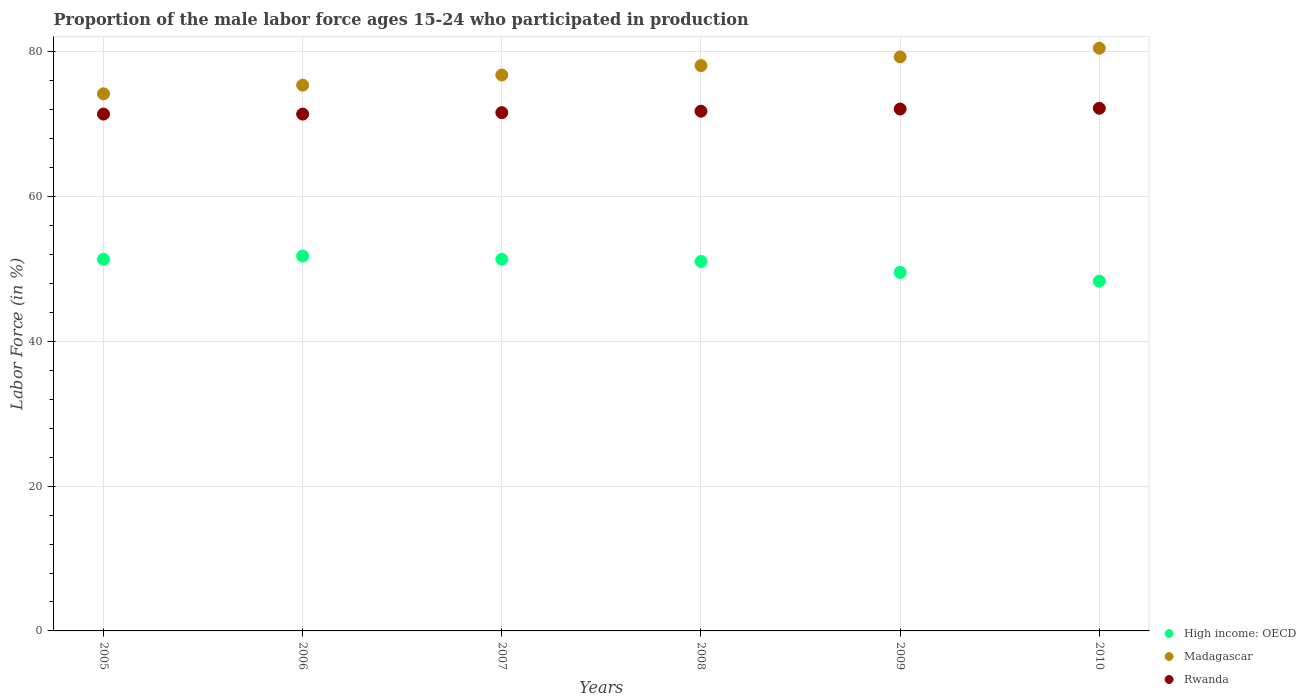What is the proportion of the male labor force who participated in production in Rwanda in 2005?
Your answer should be compact. 71.4. Across all years, what is the maximum proportion of the male labor force who participated in production in High income: OECD?
Provide a succinct answer. 51.79. Across all years, what is the minimum proportion of the male labor force who participated in production in Madagascar?
Ensure brevity in your answer.  74.2. In which year was the proportion of the male labor force who participated in production in High income: OECD maximum?
Your answer should be very brief. 2006. In which year was the proportion of the male labor force who participated in production in Madagascar minimum?
Your response must be concise. 2005. What is the total proportion of the male labor force who participated in production in Rwanda in the graph?
Your response must be concise. 430.5. What is the difference between the proportion of the male labor force who participated in production in High income: OECD in 2009 and that in 2010?
Give a very brief answer. 1.21. What is the difference between the proportion of the male labor force who participated in production in High income: OECD in 2005 and the proportion of the male labor force who participated in production in Madagascar in 2007?
Your answer should be very brief. -25.45. What is the average proportion of the male labor force who participated in production in High income: OECD per year?
Your response must be concise. 50.56. In the year 2005, what is the difference between the proportion of the male labor force who participated in production in High income: OECD and proportion of the male labor force who participated in production in Madagascar?
Your answer should be compact. -22.85. What is the ratio of the proportion of the male labor force who participated in production in Madagascar in 2007 to that in 2008?
Your response must be concise. 0.98. Is the difference between the proportion of the male labor force who participated in production in High income: OECD in 2005 and 2007 greater than the difference between the proportion of the male labor force who participated in production in Madagascar in 2005 and 2007?
Provide a succinct answer. Yes. What is the difference between the highest and the second highest proportion of the male labor force who participated in production in Rwanda?
Ensure brevity in your answer.  0.1. What is the difference between the highest and the lowest proportion of the male labor force who participated in production in Rwanda?
Offer a very short reply. 0.8. Is it the case that in every year, the sum of the proportion of the male labor force who participated in production in Rwanda and proportion of the male labor force who participated in production in Madagascar  is greater than the proportion of the male labor force who participated in production in High income: OECD?
Your answer should be compact. Yes. Is the proportion of the male labor force who participated in production in High income: OECD strictly greater than the proportion of the male labor force who participated in production in Madagascar over the years?
Provide a short and direct response. No. Is the proportion of the male labor force who participated in production in Madagascar strictly less than the proportion of the male labor force who participated in production in High income: OECD over the years?
Ensure brevity in your answer.  No. What is the difference between two consecutive major ticks on the Y-axis?
Provide a short and direct response. 20. Are the values on the major ticks of Y-axis written in scientific E-notation?
Your answer should be very brief. No. Does the graph contain grids?
Offer a very short reply. Yes. Where does the legend appear in the graph?
Keep it short and to the point. Bottom right. How many legend labels are there?
Provide a succinct answer. 3. What is the title of the graph?
Offer a very short reply. Proportion of the male labor force ages 15-24 who participated in production. What is the Labor Force (in %) of High income: OECD in 2005?
Make the answer very short. 51.35. What is the Labor Force (in %) in Madagascar in 2005?
Offer a very short reply. 74.2. What is the Labor Force (in %) of Rwanda in 2005?
Your response must be concise. 71.4. What is the Labor Force (in %) of High income: OECD in 2006?
Provide a succinct answer. 51.79. What is the Labor Force (in %) of Madagascar in 2006?
Your answer should be very brief. 75.4. What is the Labor Force (in %) of Rwanda in 2006?
Give a very brief answer. 71.4. What is the Labor Force (in %) of High income: OECD in 2007?
Your answer should be compact. 51.35. What is the Labor Force (in %) in Madagascar in 2007?
Your answer should be very brief. 76.8. What is the Labor Force (in %) in Rwanda in 2007?
Your answer should be very brief. 71.6. What is the Labor Force (in %) of High income: OECD in 2008?
Offer a very short reply. 51.04. What is the Labor Force (in %) in Madagascar in 2008?
Offer a very short reply. 78.1. What is the Labor Force (in %) of Rwanda in 2008?
Give a very brief answer. 71.8. What is the Labor Force (in %) in High income: OECD in 2009?
Provide a succinct answer. 49.54. What is the Labor Force (in %) in Madagascar in 2009?
Your answer should be compact. 79.3. What is the Labor Force (in %) in Rwanda in 2009?
Make the answer very short. 72.1. What is the Labor Force (in %) in High income: OECD in 2010?
Provide a short and direct response. 48.33. What is the Labor Force (in %) of Madagascar in 2010?
Give a very brief answer. 80.5. What is the Labor Force (in %) in Rwanda in 2010?
Make the answer very short. 72.2. Across all years, what is the maximum Labor Force (in %) of High income: OECD?
Your response must be concise. 51.79. Across all years, what is the maximum Labor Force (in %) in Madagascar?
Provide a short and direct response. 80.5. Across all years, what is the maximum Labor Force (in %) of Rwanda?
Make the answer very short. 72.2. Across all years, what is the minimum Labor Force (in %) of High income: OECD?
Provide a short and direct response. 48.33. Across all years, what is the minimum Labor Force (in %) of Madagascar?
Provide a succinct answer. 74.2. Across all years, what is the minimum Labor Force (in %) of Rwanda?
Provide a succinct answer. 71.4. What is the total Labor Force (in %) in High income: OECD in the graph?
Provide a succinct answer. 303.39. What is the total Labor Force (in %) of Madagascar in the graph?
Provide a short and direct response. 464.3. What is the total Labor Force (in %) of Rwanda in the graph?
Ensure brevity in your answer.  430.5. What is the difference between the Labor Force (in %) of High income: OECD in 2005 and that in 2006?
Ensure brevity in your answer.  -0.44. What is the difference between the Labor Force (in %) of Rwanda in 2005 and that in 2006?
Your answer should be very brief. 0. What is the difference between the Labor Force (in %) in High income: OECD in 2005 and that in 2007?
Your response must be concise. -0. What is the difference between the Labor Force (in %) in High income: OECD in 2005 and that in 2008?
Give a very brief answer. 0.31. What is the difference between the Labor Force (in %) of High income: OECD in 2005 and that in 2009?
Give a very brief answer. 1.81. What is the difference between the Labor Force (in %) in Madagascar in 2005 and that in 2009?
Offer a very short reply. -5.1. What is the difference between the Labor Force (in %) in Rwanda in 2005 and that in 2009?
Provide a succinct answer. -0.7. What is the difference between the Labor Force (in %) in High income: OECD in 2005 and that in 2010?
Give a very brief answer. 3.02. What is the difference between the Labor Force (in %) in Madagascar in 2005 and that in 2010?
Offer a very short reply. -6.3. What is the difference between the Labor Force (in %) in High income: OECD in 2006 and that in 2007?
Keep it short and to the point. 0.44. What is the difference between the Labor Force (in %) of Madagascar in 2006 and that in 2007?
Your answer should be compact. -1.4. What is the difference between the Labor Force (in %) in Rwanda in 2006 and that in 2007?
Your answer should be very brief. -0.2. What is the difference between the Labor Force (in %) in High income: OECD in 2006 and that in 2008?
Provide a short and direct response. 0.75. What is the difference between the Labor Force (in %) in Rwanda in 2006 and that in 2008?
Provide a short and direct response. -0.4. What is the difference between the Labor Force (in %) in High income: OECD in 2006 and that in 2009?
Give a very brief answer. 2.25. What is the difference between the Labor Force (in %) of Madagascar in 2006 and that in 2009?
Offer a very short reply. -3.9. What is the difference between the Labor Force (in %) in Rwanda in 2006 and that in 2009?
Your answer should be very brief. -0.7. What is the difference between the Labor Force (in %) of High income: OECD in 2006 and that in 2010?
Ensure brevity in your answer.  3.46. What is the difference between the Labor Force (in %) in Madagascar in 2006 and that in 2010?
Keep it short and to the point. -5.1. What is the difference between the Labor Force (in %) in High income: OECD in 2007 and that in 2008?
Provide a succinct answer. 0.31. What is the difference between the Labor Force (in %) of Rwanda in 2007 and that in 2008?
Offer a terse response. -0.2. What is the difference between the Labor Force (in %) of High income: OECD in 2007 and that in 2009?
Offer a terse response. 1.82. What is the difference between the Labor Force (in %) of Rwanda in 2007 and that in 2009?
Your answer should be compact. -0.5. What is the difference between the Labor Force (in %) of High income: OECD in 2007 and that in 2010?
Your answer should be very brief. 3.03. What is the difference between the Labor Force (in %) in Rwanda in 2007 and that in 2010?
Your response must be concise. -0.6. What is the difference between the Labor Force (in %) of High income: OECD in 2008 and that in 2009?
Ensure brevity in your answer.  1.5. What is the difference between the Labor Force (in %) in High income: OECD in 2008 and that in 2010?
Ensure brevity in your answer.  2.71. What is the difference between the Labor Force (in %) of Madagascar in 2008 and that in 2010?
Your answer should be very brief. -2.4. What is the difference between the Labor Force (in %) of Rwanda in 2008 and that in 2010?
Make the answer very short. -0.4. What is the difference between the Labor Force (in %) of High income: OECD in 2009 and that in 2010?
Provide a succinct answer. 1.21. What is the difference between the Labor Force (in %) of Madagascar in 2009 and that in 2010?
Offer a very short reply. -1.2. What is the difference between the Labor Force (in %) of Rwanda in 2009 and that in 2010?
Keep it short and to the point. -0.1. What is the difference between the Labor Force (in %) in High income: OECD in 2005 and the Labor Force (in %) in Madagascar in 2006?
Ensure brevity in your answer.  -24.05. What is the difference between the Labor Force (in %) in High income: OECD in 2005 and the Labor Force (in %) in Rwanda in 2006?
Your answer should be compact. -20.05. What is the difference between the Labor Force (in %) of High income: OECD in 2005 and the Labor Force (in %) of Madagascar in 2007?
Ensure brevity in your answer.  -25.45. What is the difference between the Labor Force (in %) in High income: OECD in 2005 and the Labor Force (in %) in Rwanda in 2007?
Your answer should be compact. -20.25. What is the difference between the Labor Force (in %) of High income: OECD in 2005 and the Labor Force (in %) of Madagascar in 2008?
Ensure brevity in your answer.  -26.75. What is the difference between the Labor Force (in %) of High income: OECD in 2005 and the Labor Force (in %) of Rwanda in 2008?
Keep it short and to the point. -20.45. What is the difference between the Labor Force (in %) of High income: OECD in 2005 and the Labor Force (in %) of Madagascar in 2009?
Your answer should be very brief. -27.95. What is the difference between the Labor Force (in %) in High income: OECD in 2005 and the Labor Force (in %) in Rwanda in 2009?
Offer a terse response. -20.75. What is the difference between the Labor Force (in %) in High income: OECD in 2005 and the Labor Force (in %) in Madagascar in 2010?
Keep it short and to the point. -29.15. What is the difference between the Labor Force (in %) in High income: OECD in 2005 and the Labor Force (in %) in Rwanda in 2010?
Offer a very short reply. -20.85. What is the difference between the Labor Force (in %) in Madagascar in 2005 and the Labor Force (in %) in Rwanda in 2010?
Provide a succinct answer. 2. What is the difference between the Labor Force (in %) of High income: OECD in 2006 and the Labor Force (in %) of Madagascar in 2007?
Your response must be concise. -25.01. What is the difference between the Labor Force (in %) in High income: OECD in 2006 and the Labor Force (in %) in Rwanda in 2007?
Your response must be concise. -19.81. What is the difference between the Labor Force (in %) of High income: OECD in 2006 and the Labor Force (in %) of Madagascar in 2008?
Offer a terse response. -26.31. What is the difference between the Labor Force (in %) of High income: OECD in 2006 and the Labor Force (in %) of Rwanda in 2008?
Make the answer very short. -20.01. What is the difference between the Labor Force (in %) in High income: OECD in 2006 and the Labor Force (in %) in Madagascar in 2009?
Provide a short and direct response. -27.51. What is the difference between the Labor Force (in %) of High income: OECD in 2006 and the Labor Force (in %) of Rwanda in 2009?
Provide a short and direct response. -20.31. What is the difference between the Labor Force (in %) of Madagascar in 2006 and the Labor Force (in %) of Rwanda in 2009?
Your response must be concise. 3.3. What is the difference between the Labor Force (in %) of High income: OECD in 2006 and the Labor Force (in %) of Madagascar in 2010?
Ensure brevity in your answer.  -28.71. What is the difference between the Labor Force (in %) of High income: OECD in 2006 and the Labor Force (in %) of Rwanda in 2010?
Offer a terse response. -20.41. What is the difference between the Labor Force (in %) of High income: OECD in 2007 and the Labor Force (in %) of Madagascar in 2008?
Offer a very short reply. -26.75. What is the difference between the Labor Force (in %) in High income: OECD in 2007 and the Labor Force (in %) in Rwanda in 2008?
Offer a very short reply. -20.45. What is the difference between the Labor Force (in %) of Madagascar in 2007 and the Labor Force (in %) of Rwanda in 2008?
Offer a terse response. 5. What is the difference between the Labor Force (in %) in High income: OECD in 2007 and the Labor Force (in %) in Madagascar in 2009?
Make the answer very short. -27.95. What is the difference between the Labor Force (in %) of High income: OECD in 2007 and the Labor Force (in %) of Rwanda in 2009?
Give a very brief answer. -20.75. What is the difference between the Labor Force (in %) in High income: OECD in 2007 and the Labor Force (in %) in Madagascar in 2010?
Provide a succinct answer. -29.15. What is the difference between the Labor Force (in %) in High income: OECD in 2007 and the Labor Force (in %) in Rwanda in 2010?
Provide a succinct answer. -20.85. What is the difference between the Labor Force (in %) of Madagascar in 2007 and the Labor Force (in %) of Rwanda in 2010?
Make the answer very short. 4.6. What is the difference between the Labor Force (in %) of High income: OECD in 2008 and the Labor Force (in %) of Madagascar in 2009?
Provide a succinct answer. -28.26. What is the difference between the Labor Force (in %) of High income: OECD in 2008 and the Labor Force (in %) of Rwanda in 2009?
Give a very brief answer. -21.06. What is the difference between the Labor Force (in %) in Madagascar in 2008 and the Labor Force (in %) in Rwanda in 2009?
Provide a succinct answer. 6. What is the difference between the Labor Force (in %) of High income: OECD in 2008 and the Labor Force (in %) of Madagascar in 2010?
Your answer should be compact. -29.46. What is the difference between the Labor Force (in %) of High income: OECD in 2008 and the Labor Force (in %) of Rwanda in 2010?
Offer a very short reply. -21.16. What is the difference between the Labor Force (in %) of High income: OECD in 2009 and the Labor Force (in %) of Madagascar in 2010?
Make the answer very short. -30.96. What is the difference between the Labor Force (in %) of High income: OECD in 2009 and the Labor Force (in %) of Rwanda in 2010?
Ensure brevity in your answer.  -22.66. What is the average Labor Force (in %) of High income: OECD per year?
Ensure brevity in your answer.  50.56. What is the average Labor Force (in %) in Madagascar per year?
Offer a very short reply. 77.38. What is the average Labor Force (in %) of Rwanda per year?
Offer a very short reply. 71.75. In the year 2005, what is the difference between the Labor Force (in %) of High income: OECD and Labor Force (in %) of Madagascar?
Ensure brevity in your answer.  -22.85. In the year 2005, what is the difference between the Labor Force (in %) in High income: OECD and Labor Force (in %) in Rwanda?
Ensure brevity in your answer.  -20.05. In the year 2006, what is the difference between the Labor Force (in %) in High income: OECD and Labor Force (in %) in Madagascar?
Your answer should be very brief. -23.61. In the year 2006, what is the difference between the Labor Force (in %) of High income: OECD and Labor Force (in %) of Rwanda?
Offer a terse response. -19.61. In the year 2006, what is the difference between the Labor Force (in %) in Madagascar and Labor Force (in %) in Rwanda?
Give a very brief answer. 4. In the year 2007, what is the difference between the Labor Force (in %) in High income: OECD and Labor Force (in %) in Madagascar?
Your answer should be very brief. -25.45. In the year 2007, what is the difference between the Labor Force (in %) of High income: OECD and Labor Force (in %) of Rwanda?
Give a very brief answer. -20.25. In the year 2008, what is the difference between the Labor Force (in %) in High income: OECD and Labor Force (in %) in Madagascar?
Your answer should be compact. -27.06. In the year 2008, what is the difference between the Labor Force (in %) in High income: OECD and Labor Force (in %) in Rwanda?
Provide a succinct answer. -20.76. In the year 2009, what is the difference between the Labor Force (in %) in High income: OECD and Labor Force (in %) in Madagascar?
Provide a succinct answer. -29.76. In the year 2009, what is the difference between the Labor Force (in %) of High income: OECD and Labor Force (in %) of Rwanda?
Offer a terse response. -22.56. In the year 2009, what is the difference between the Labor Force (in %) of Madagascar and Labor Force (in %) of Rwanda?
Your answer should be very brief. 7.2. In the year 2010, what is the difference between the Labor Force (in %) in High income: OECD and Labor Force (in %) in Madagascar?
Your answer should be very brief. -32.17. In the year 2010, what is the difference between the Labor Force (in %) in High income: OECD and Labor Force (in %) in Rwanda?
Offer a terse response. -23.87. What is the ratio of the Labor Force (in %) in Madagascar in 2005 to that in 2006?
Ensure brevity in your answer.  0.98. What is the ratio of the Labor Force (in %) of High income: OECD in 2005 to that in 2007?
Ensure brevity in your answer.  1. What is the ratio of the Labor Force (in %) in Madagascar in 2005 to that in 2007?
Keep it short and to the point. 0.97. What is the ratio of the Labor Force (in %) of Rwanda in 2005 to that in 2007?
Keep it short and to the point. 1. What is the ratio of the Labor Force (in %) in High income: OECD in 2005 to that in 2008?
Your response must be concise. 1.01. What is the ratio of the Labor Force (in %) of Madagascar in 2005 to that in 2008?
Your response must be concise. 0.95. What is the ratio of the Labor Force (in %) in Rwanda in 2005 to that in 2008?
Your answer should be compact. 0.99. What is the ratio of the Labor Force (in %) of High income: OECD in 2005 to that in 2009?
Make the answer very short. 1.04. What is the ratio of the Labor Force (in %) of Madagascar in 2005 to that in 2009?
Your answer should be very brief. 0.94. What is the ratio of the Labor Force (in %) of Rwanda in 2005 to that in 2009?
Your answer should be compact. 0.99. What is the ratio of the Labor Force (in %) in High income: OECD in 2005 to that in 2010?
Offer a terse response. 1.06. What is the ratio of the Labor Force (in %) of Madagascar in 2005 to that in 2010?
Your answer should be very brief. 0.92. What is the ratio of the Labor Force (in %) of Rwanda in 2005 to that in 2010?
Give a very brief answer. 0.99. What is the ratio of the Labor Force (in %) in High income: OECD in 2006 to that in 2007?
Offer a terse response. 1.01. What is the ratio of the Labor Force (in %) of Madagascar in 2006 to that in 2007?
Provide a succinct answer. 0.98. What is the ratio of the Labor Force (in %) of Rwanda in 2006 to that in 2007?
Offer a terse response. 1. What is the ratio of the Labor Force (in %) of High income: OECD in 2006 to that in 2008?
Make the answer very short. 1.01. What is the ratio of the Labor Force (in %) of Madagascar in 2006 to that in 2008?
Your answer should be very brief. 0.97. What is the ratio of the Labor Force (in %) of Rwanda in 2006 to that in 2008?
Provide a short and direct response. 0.99. What is the ratio of the Labor Force (in %) of High income: OECD in 2006 to that in 2009?
Ensure brevity in your answer.  1.05. What is the ratio of the Labor Force (in %) in Madagascar in 2006 to that in 2009?
Ensure brevity in your answer.  0.95. What is the ratio of the Labor Force (in %) of Rwanda in 2006 to that in 2009?
Provide a short and direct response. 0.99. What is the ratio of the Labor Force (in %) in High income: OECD in 2006 to that in 2010?
Provide a short and direct response. 1.07. What is the ratio of the Labor Force (in %) in Madagascar in 2006 to that in 2010?
Offer a terse response. 0.94. What is the ratio of the Labor Force (in %) in Rwanda in 2006 to that in 2010?
Provide a short and direct response. 0.99. What is the ratio of the Labor Force (in %) in Madagascar in 2007 to that in 2008?
Your answer should be very brief. 0.98. What is the ratio of the Labor Force (in %) in High income: OECD in 2007 to that in 2009?
Your answer should be very brief. 1.04. What is the ratio of the Labor Force (in %) of Madagascar in 2007 to that in 2009?
Your response must be concise. 0.97. What is the ratio of the Labor Force (in %) of High income: OECD in 2007 to that in 2010?
Your answer should be very brief. 1.06. What is the ratio of the Labor Force (in %) in Madagascar in 2007 to that in 2010?
Make the answer very short. 0.95. What is the ratio of the Labor Force (in %) in Rwanda in 2007 to that in 2010?
Provide a succinct answer. 0.99. What is the ratio of the Labor Force (in %) in High income: OECD in 2008 to that in 2009?
Your answer should be compact. 1.03. What is the ratio of the Labor Force (in %) in Madagascar in 2008 to that in 2009?
Your answer should be very brief. 0.98. What is the ratio of the Labor Force (in %) of Rwanda in 2008 to that in 2009?
Provide a short and direct response. 1. What is the ratio of the Labor Force (in %) in High income: OECD in 2008 to that in 2010?
Keep it short and to the point. 1.06. What is the ratio of the Labor Force (in %) of Madagascar in 2008 to that in 2010?
Your response must be concise. 0.97. What is the ratio of the Labor Force (in %) of Madagascar in 2009 to that in 2010?
Keep it short and to the point. 0.99. What is the ratio of the Labor Force (in %) of Rwanda in 2009 to that in 2010?
Your answer should be compact. 1. What is the difference between the highest and the second highest Labor Force (in %) of High income: OECD?
Ensure brevity in your answer.  0.44. What is the difference between the highest and the second highest Labor Force (in %) of Madagascar?
Your response must be concise. 1.2. What is the difference between the highest and the second highest Labor Force (in %) of Rwanda?
Your response must be concise. 0.1. What is the difference between the highest and the lowest Labor Force (in %) in High income: OECD?
Your response must be concise. 3.46. What is the difference between the highest and the lowest Labor Force (in %) of Rwanda?
Keep it short and to the point. 0.8. 